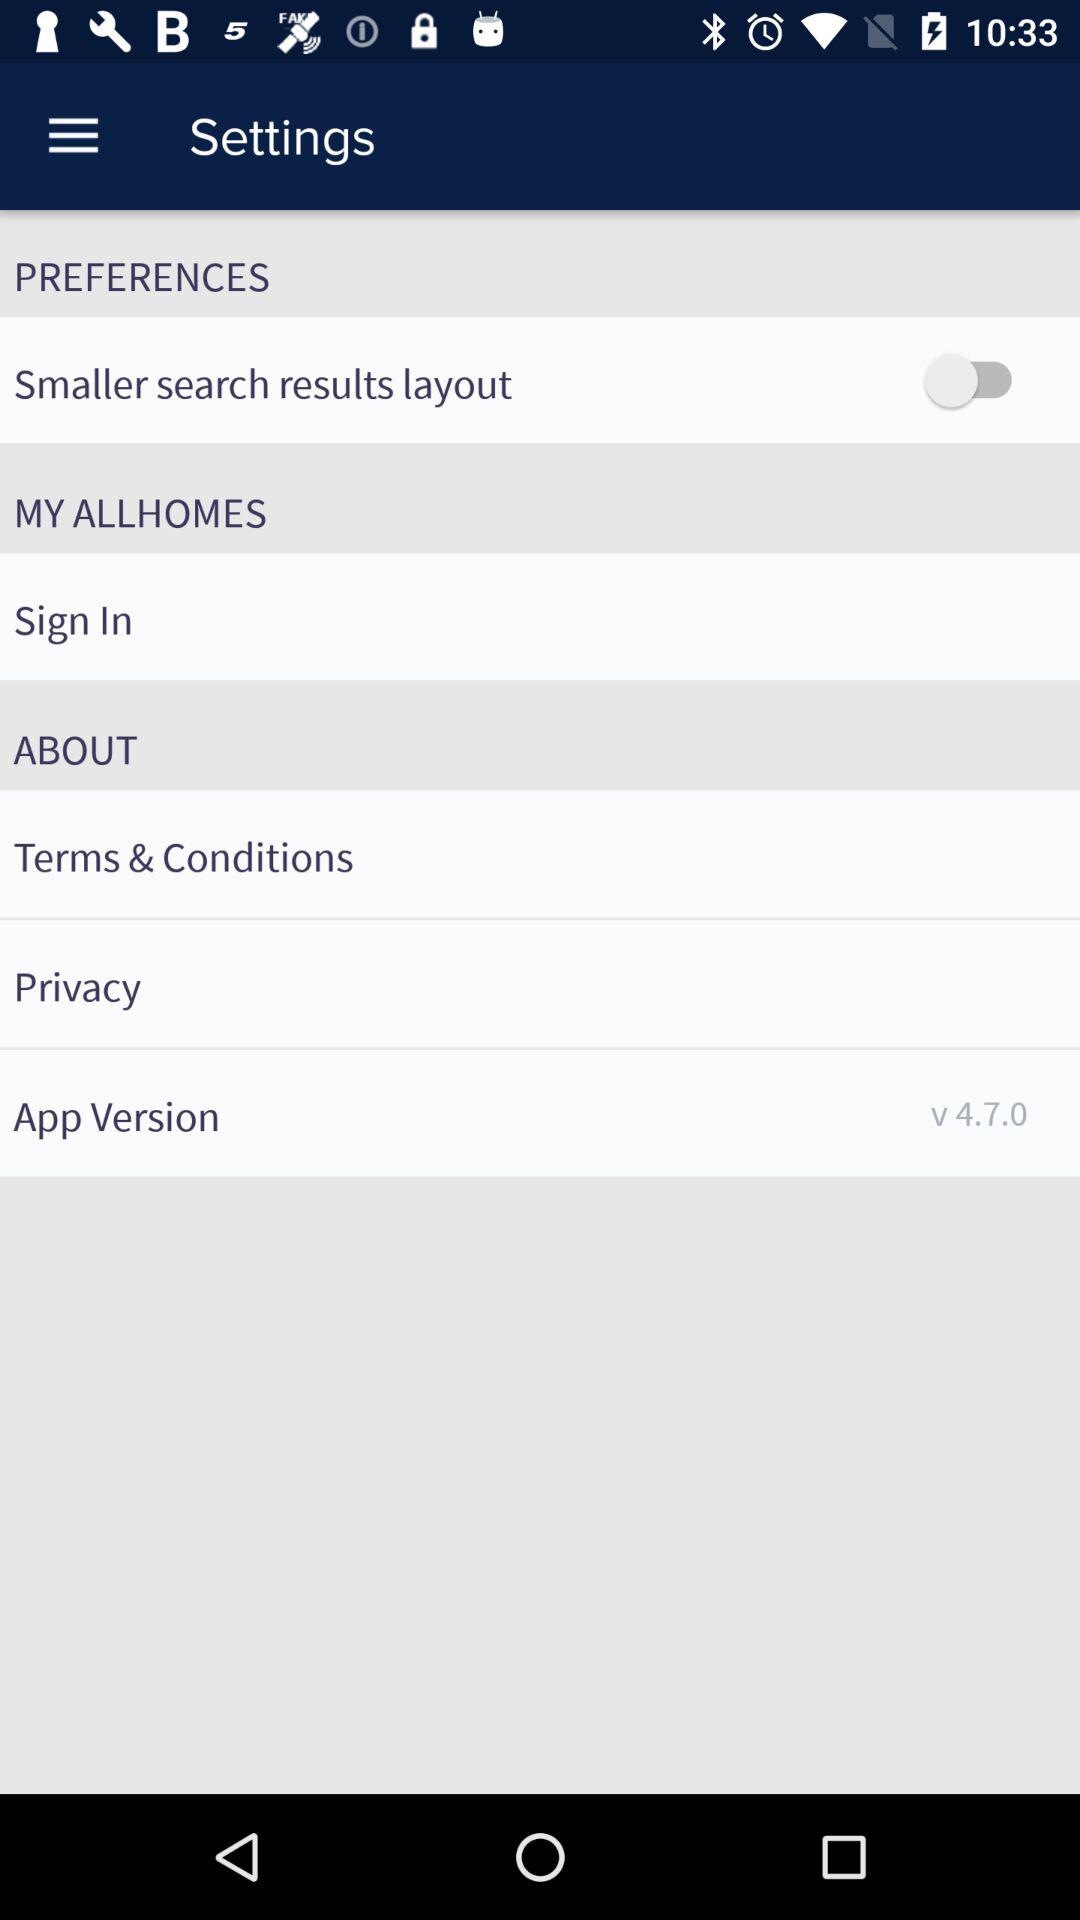What is the version? The version is v 4.7.0. 